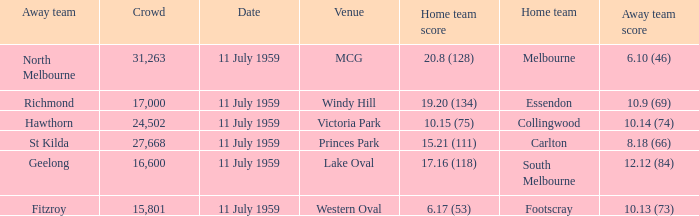What is the home team's score when richmond is away? 19.20 (134). Would you mind parsing the complete table? {'header': ['Away team', 'Crowd', 'Date', 'Venue', 'Home team score', 'Home team', 'Away team score'], 'rows': [['North Melbourne', '31,263', '11 July 1959', 'MCG', '20.8 (128)', 'Melbourne', '6.10 (46)'], ['Richmond', '17,000', '11 July 1959', 'Windy Hill', '19.20 (134)', 'Essendon', '10.9 (69)'], ['Hawthorn', '24,502', '11 July 1959', 'Victoria Park', '10.15 (75)', 'Collingwood', '10.14 (74)'], ['St Kilda', '27,668', '11 July 1959', 'Princes Park', '15.21 (111)', 'Carlton', '8.18 (66)'], ['Geelong', '16,600', '11 July 1959', 'Lake Oval', '17.16 (118)', 'South Melbourne', '12.12 (84)'], ['Fitzroy', '15,801', '11 July 1959', 'Western Oval', '6.17 (53)', 'Footscray', '10.13 (73)']]} 